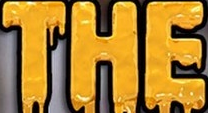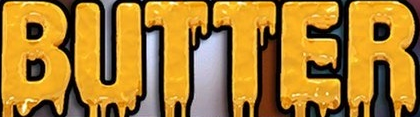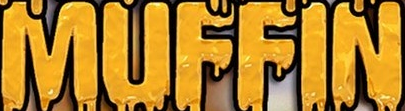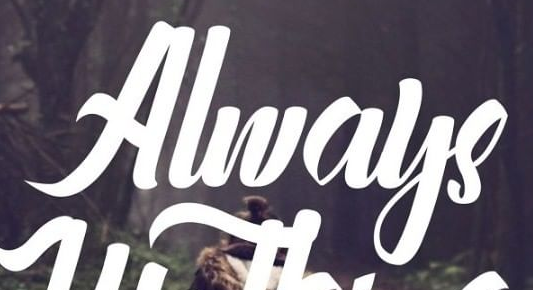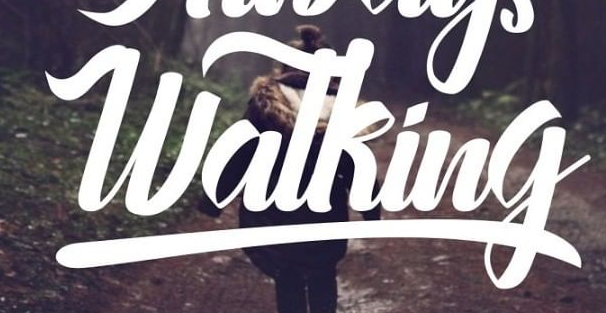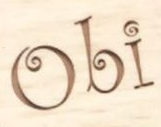What text appears in these images from left to right, separated by a semicolon? THE; BUTTER; MUFFIN; Always; Watking; Obi 